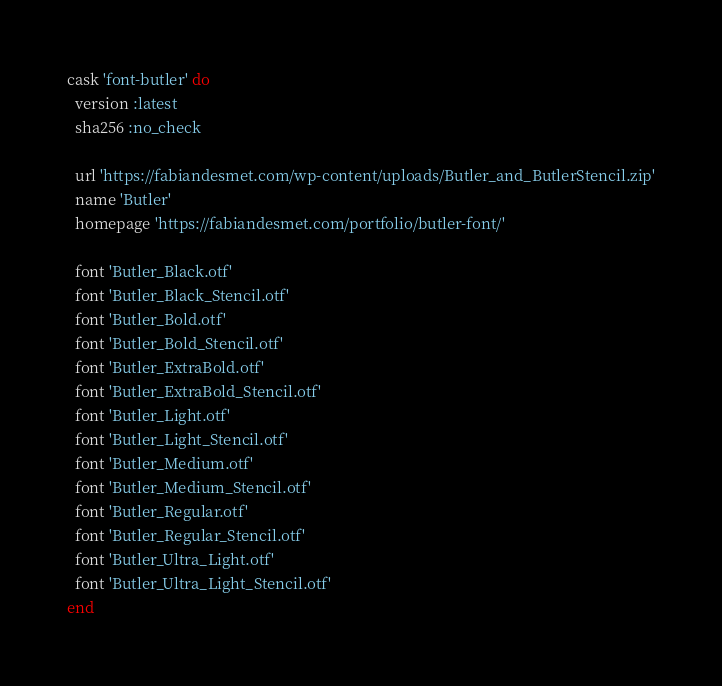Convert code to text. <code><loc_0><loc_0><loc_500><loc_500><_Ruby_>cask 'font-butler' do
  version :latest
  sha256 :no_check

  url 'https://fabiandesmet.com/wp-content/uploads/Butler_and_ButlerStencil.zip'
  name 'Butler'
  homepage 'https://fabiandesmet.com/portfolio/butler-font/'

  font 'Butler_Black.otf'
  font 'Butler_Black_Stencil.otf'
  font 'Butler_Bold.otf'
  font 'Butler_Bold_Stencil.otf'
  font 'Butler_ExtraBold.otf'
  font 'Butler_ExtraBold_Stencil.otf'
  font 'Butler_Light.otf'
  font 'Butler_Light_Stencil.otf'
  font 'Butler_Medium.otf'
  font 'Butler_Medium_Stencil.otf'
  font 'Butler_Regular.otf'
  font 'Butler_Regular_Stencil.otf'
  font 'Butler_Ultra_Light.otf'
  font 'Butler_Ultra_Light_Stencil.otf'
end
</code> 